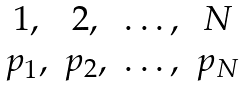Convert formula to latex. <formula><loc_0><loc_0><loc_500><loc_500>\begin{matrix} 1 , & 2 , & \dots , & N \\ p _ { 1 } , & p _ { 2 } , & \dots , & p _ { N } \end{matrix}</formula> 